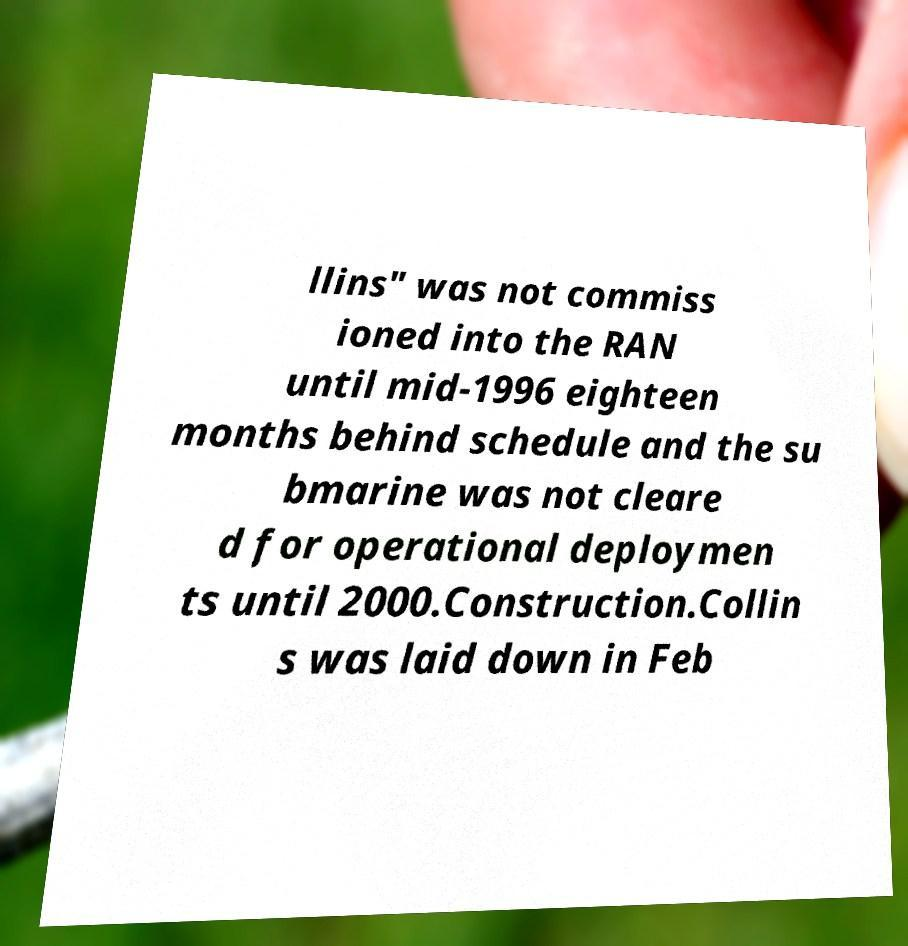Can you read and provide the text displayed in the image?This photo seems to have some interesting text. Can you extract and type it out for me? llins" was not commiss ioned into the RAN until mid-1996 eighteen months behind schedule and the su bmarine was not cleare d for operational deploymen ts until 2000.Construction.Collin s was laid down in Feb 